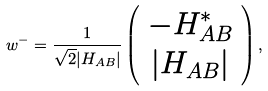Convert formula to latex. <formula><loc_0><loc_0><loc_500><loc_500>w ^ { - } = \frac { 1 } { \sqrt { 2 } | H _ { A B } | } \left ( \begin{array} { c } - H _ { A B } ^ { * } \\ | H _ { A B } | \end{array} \right ) ,</formula> 